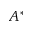Convert formula to latex. <formula><loc_0><loc_0><loc_500><loc_500>A ^ { \ast }</formula> 